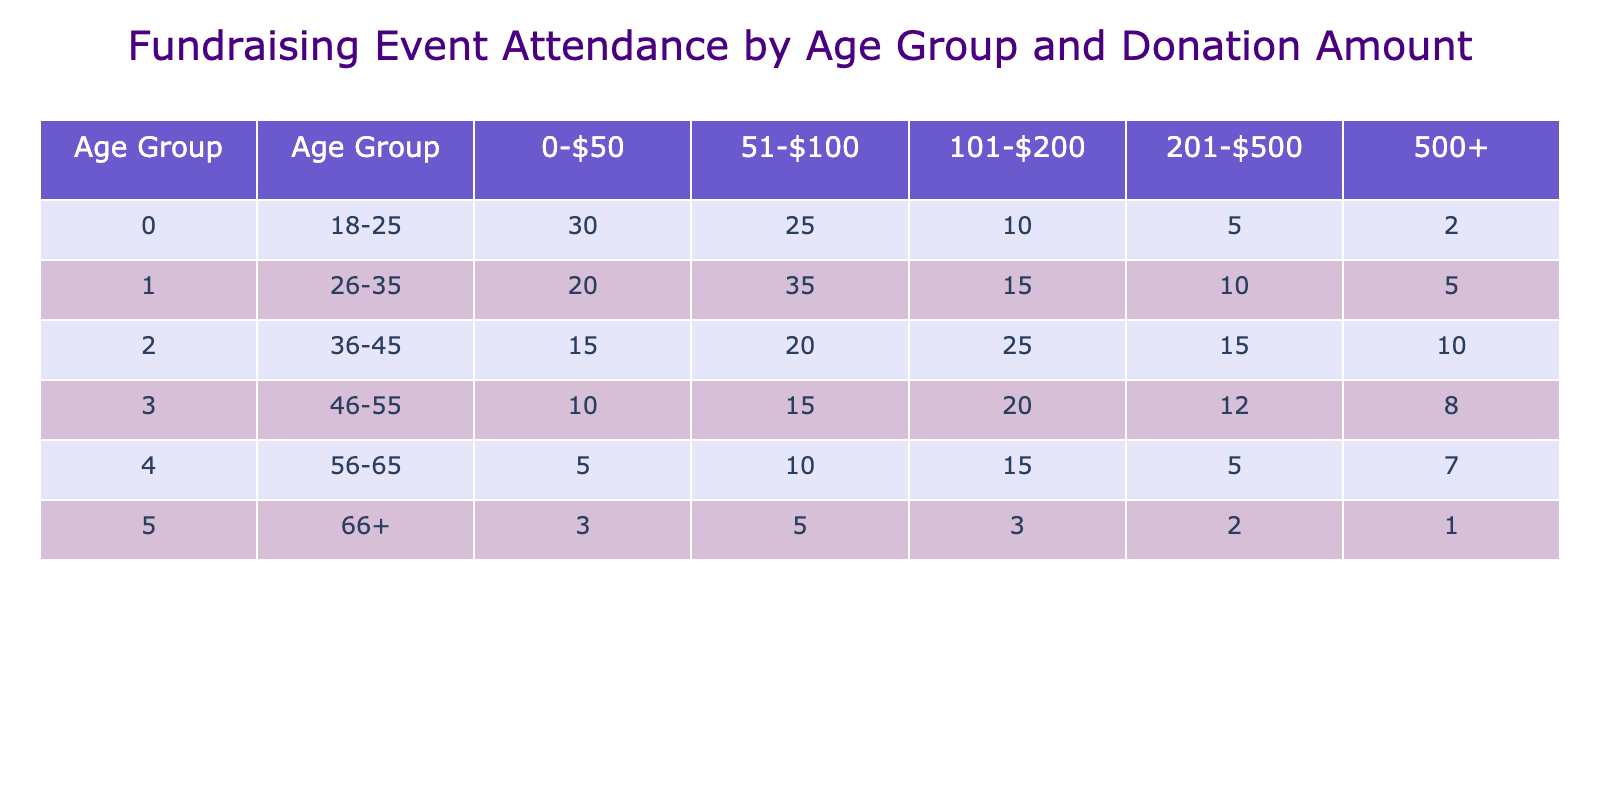What is the highest attendance for a donation range across all age groups? The highest attendance is found by identifying the maximum value in the table. Scanning the table, the value of 35 occurs in the age group 26-35 for the donation range 51-$100.
Answer: 35 What is the total number of attendees aged 18-25 who donated over $100? To find this, we sum the number of attendees in the 18-25 age group for the donation ranges over $100, which are 10 (101-$200), 5 (201-$500), and 2 (500+). Thus, 10 + 5 + 2 = 17.
Answer: 17 Is there a donation range where attendees aged 66+ are greater than those aged 56-65? In both age groups, we compare the number of attendees for each donation range. In the 66+ age group, the largest count is 5 (51-$100). In the 56-65 age group, there are 10 (51-$100) and 15 (101-$200), hence no range shows greater attendance for 66+.
Answer: No What is the average number of attendees in the 36-45 age group across all donation ranges? First, we add all attendees in the 36-45 age group: 15 + 20 + 25 + 15 + 10 = 95. Then divide by the number of donation ranges, which is 5: 95 / 5 = 19.
Answer: 19 Which age group had the least attendance in the 500+ donation range? Examining the table, the 66+ age group has 1 attendee in the 500+ range, which is the least compared to other groups.
Answer: 66+ 